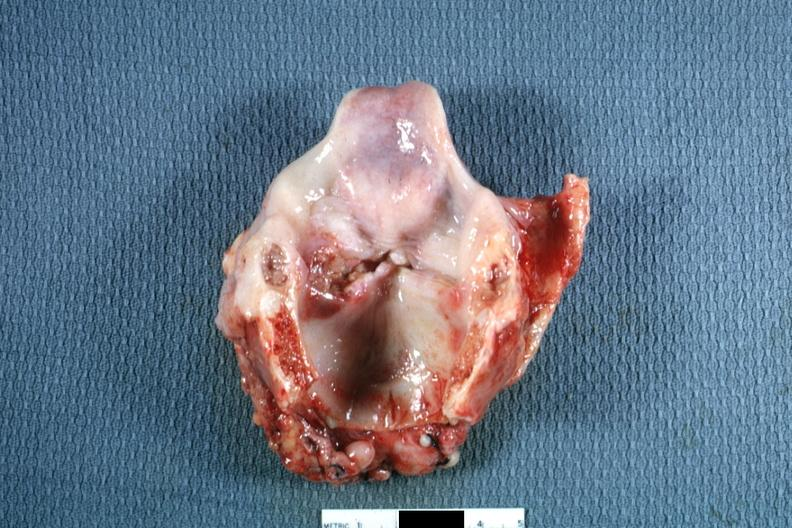what is present?
Answer the question using a single word or phrase. Squamous cell carcinoma 